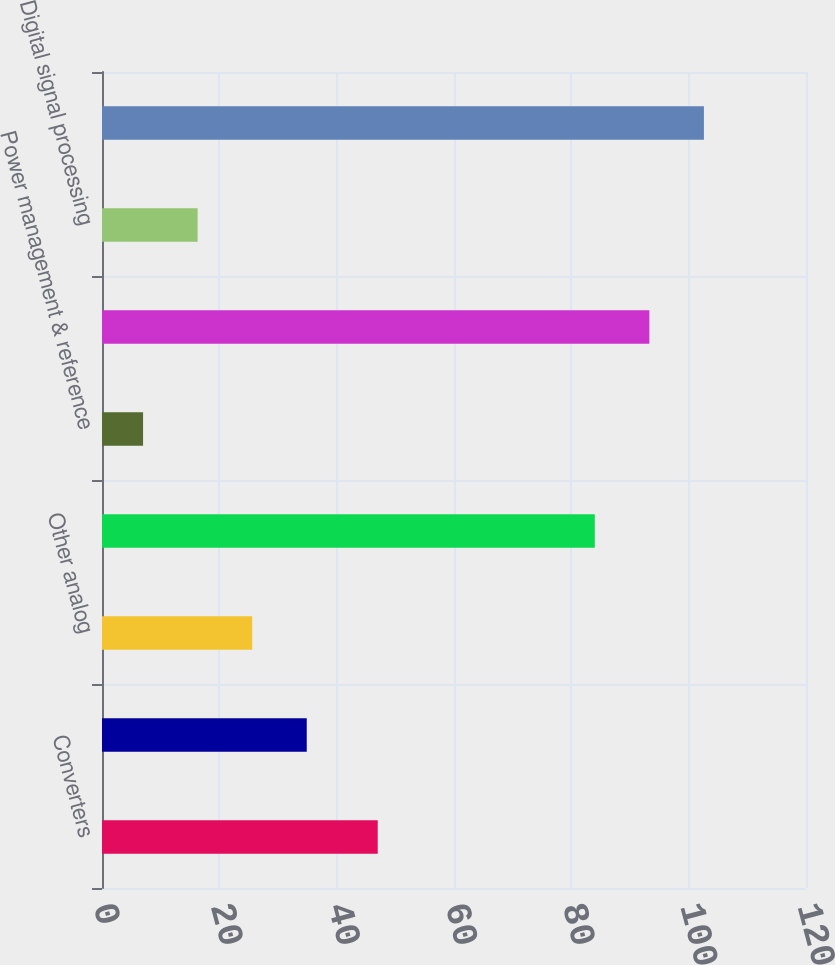Convert chart. <chart><loc_0><loc_0><loc_500><loc_500><bar_chart><fcel>Converters<fcel>Amplifiers/Radio frequency<fcel>Other analog<fcel>Subtotal analog signal<fcel>Power management & reference<fcel>Total analog products<fcel>Digital signal processing<fcel>Total Revenue<nl><fcel>47<fcel>34.9<fcel>25.6<fcel>84<fcel>7<fcel>93.3<fcel>16.3<fcel>102.6<nl></chart> 